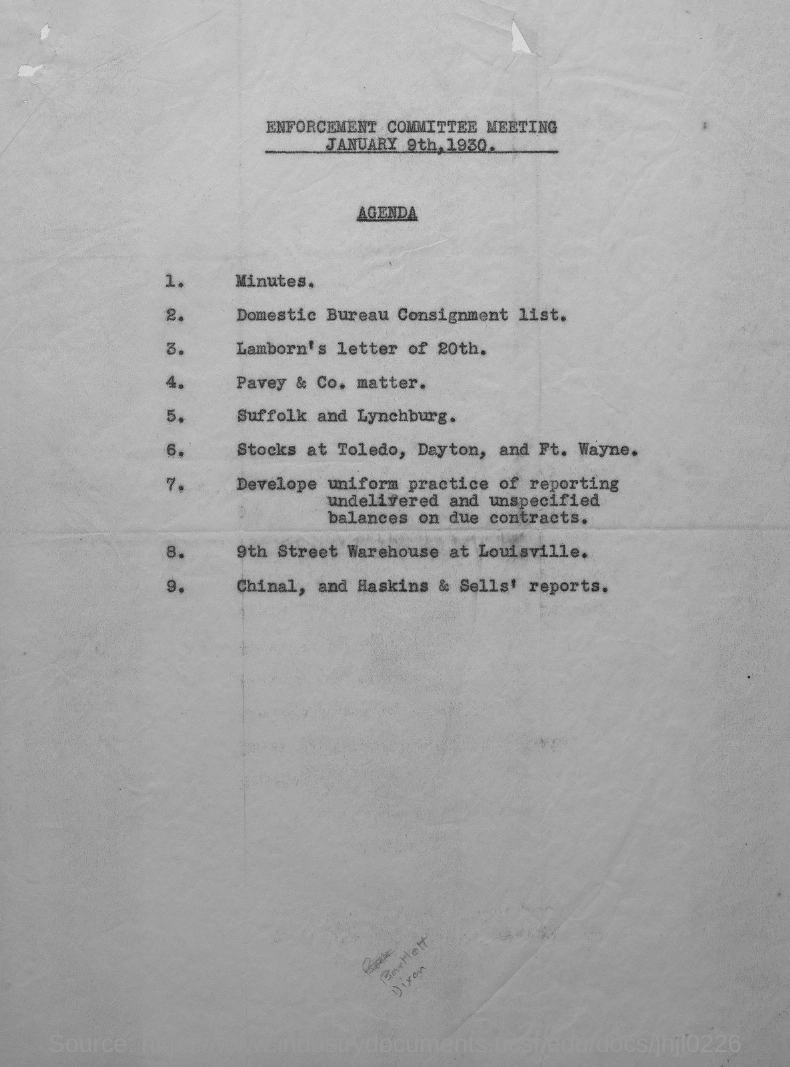Indicate a few pertinent items in this graphic. The enforcement committee meeting will be held on January 9th, 1930. The meeting agenda presented is the Enforcement Committee Meeting. 